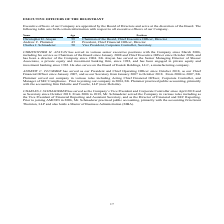From Amcon Distributing's financial document, How old are the company's executive officers? The document contains multiple relevant values: 59, 45, 50. From the document: "Andrew C. Plummer 45 President, Chief Financial Officer, Director Christopher H. Atayan 59 Chairman of the Board, Chief Executive Officer, Director Ch..." Also, Who are the executive officers of the company? The document contains multiple relevant values: Christopher H. Atayan, Andrew C. Plummer, Charles J. Schmaderer. From the document: "Andrew C. Plummer 45 President, Chief Financial Officer, Director Christopher H. Atayan 59 Chairman of the Board, Chief Executive Officer, Director Ch..." Also, Where did Charles J. Schmaderer practice public accounting at? According to the financial document, Grant Thornton, LLP. The relevant text states: "ic accounting, primarily with the accounting firm Grant Thornton, LLP and also holds a Master of Business Administration (MBA)...." Also, can you calculate: What is the average age of the company's executive officers? To answer this question, I need to perform calculations using the financial data. The calculation is: (59 + 45 + 50)/3 , which equals 51.33. This is based on the information: "Andrew C. Plummer 45 President, Chief Financial Officer, Director Christopher H. Atayan 59 Chairman of the Board, Chief Executive Officer, Director Charles J. Schmaderer 50 Vice President, Corporate C..." The key data points involved are: 45, 50, 59. Also, can you calculate: What is the average age of the company's President and Vice President? To answer this question, I need to perform calculations using the financial data. The calculation is: (45 + 50)/2 , which equals 47.5. This is based on the information: "Andrew C. Plummer 45 President, Chief Financial Officer, Director Charles J. Schmaderer 50 Vice President, Corporate Controller, Secretary CHRISTOPHER H. ATAYAN has served in various senior..." The key data points involved are: 45, 50. Also, can you calculate: What is the average age of the company's Chief Executive and Chief Financial Officers? To answer this question, I need to perform calculations using the financial data. The calculation is: (59 + 45)/2 , which equals 52. This is based on the information: "Andrew C. Plummer 45 President, Chief Financial Officer, Director Christopher H. Atayan 59 Chairman of the Board, Chief Executive Officer, Director..." The key data points involved are: 45, 59. 